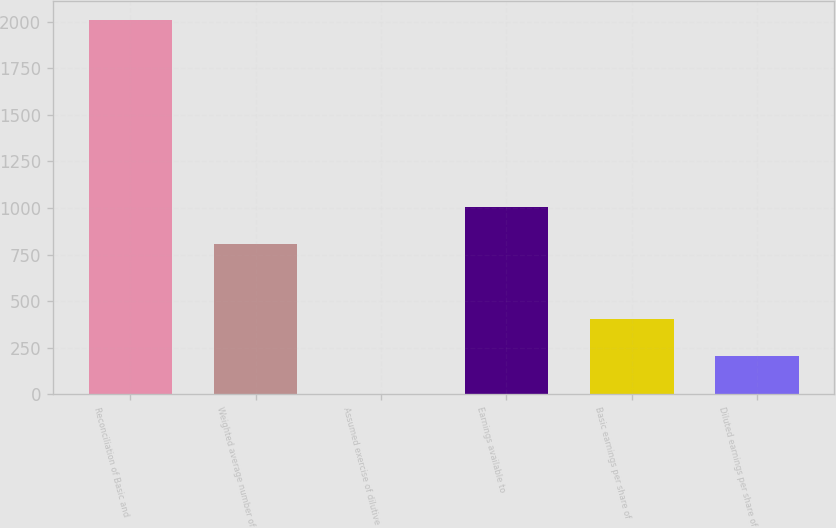<chart> <loc_0><loc_0><loc_500><loc_500><bar_chart><fcel>Reconciliation of Basic and<fcel>Weighted average number of<fcel>Assumed exercise of dilutive<fcel>Earnings available to<fcel>Basic earnings per share of<fcel>Diluted earnings per share of<nl><fcel>2012<fcel>805.4<fcel>1<fcel>1006.5<fcel>403.2<fcel>202.1<nl></chart> 